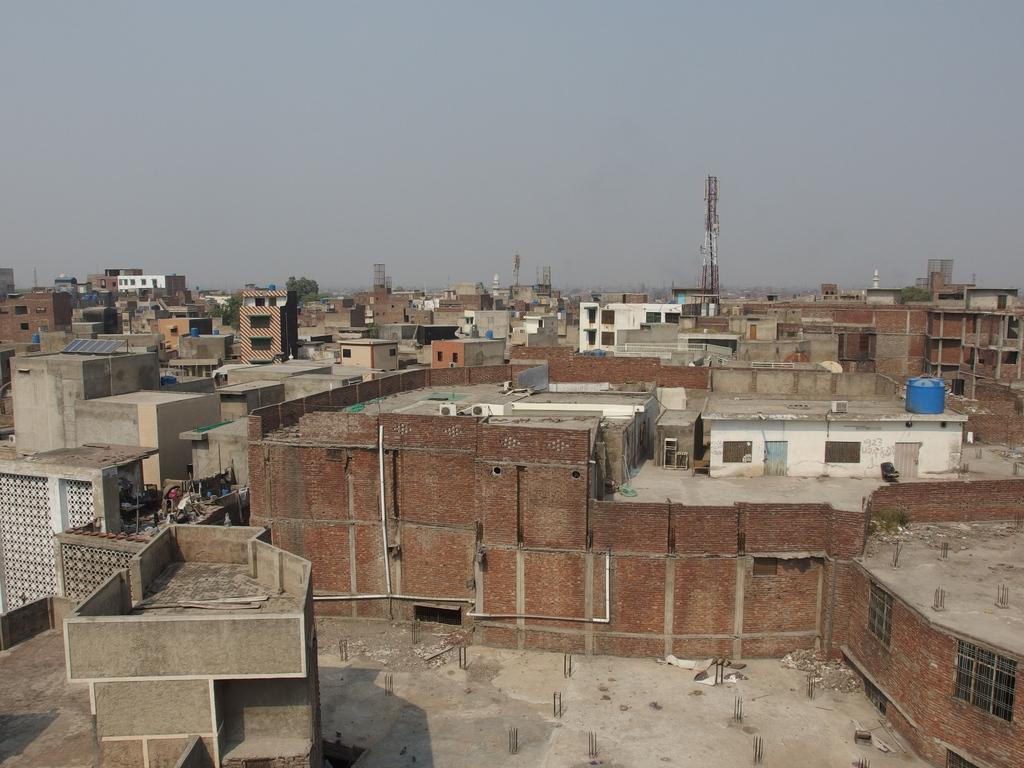What type of material is used for the walls of the buildings in the image? The buildings have brick walls. What other features can be seen on the buildings? The buildings have pipes and windows. What can be seen in the background of the image? The sky is visible in the background. What tall structures are present in the image? There are towers in the image. What is located on top of one of the buildings? There is a water tank on a building. What type of pot is being used to act as a veil in the image? There is no pot or veil present in the image; the image features buildings with brick walls, pipes, windows, towers, and a water tank. 